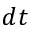Convert formula to latex. <formula><loc_0><loc_0><loc_500><loc_500>d t</formula> 